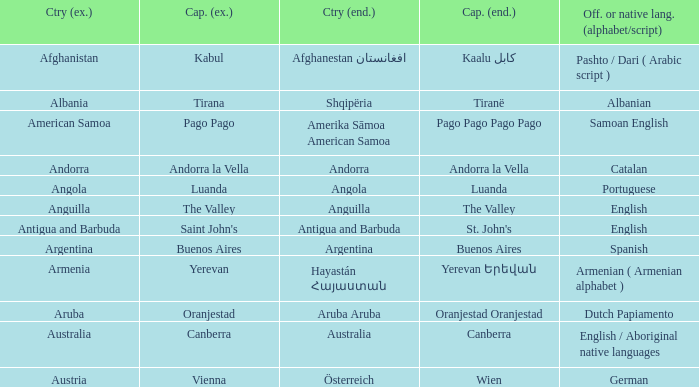How many capital cities does Australia have? 1.0. 